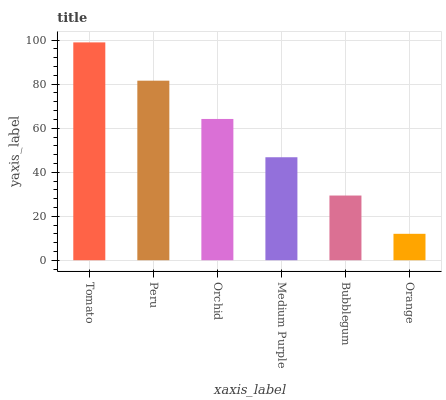Is Peru the minimum?
Answer yes or no. No. Is Peru the maximum?
Answer yes or no. No. Is Tomato greater than Peru?
Answer yes or no. Yes. Is Peru less than Tomato?
Answer yes or no. Yes. Is Peru greater than Tomato?
Answer yes or no. No. Is Tomato less than Peru?
Answer yes or no. No. Is Orchid the high median?
Answer yes or no. Yes. Is Medium Purple the low median?
Answer yes or no. Yes. Is Bubblegum the high median?
Answer yes or no. No. Is Orange the low median?
Answer yes or no. No. 